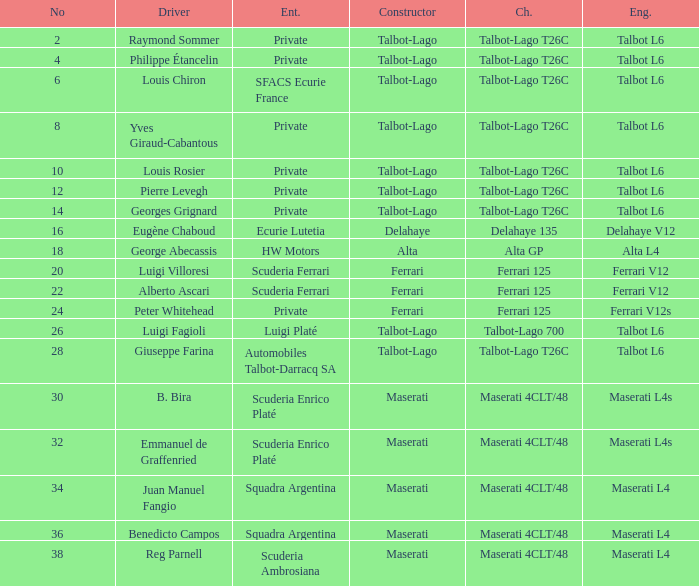Name the constructor for b. bira Maserati. 